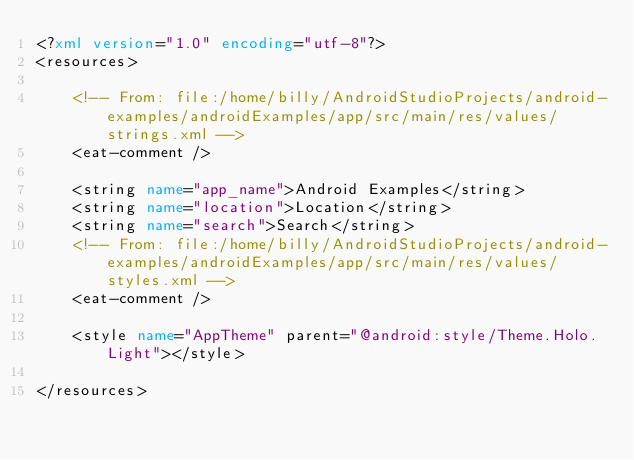Convert code to text. <code><loc_0><loc_0><loc_500><loc_500><_XML_><?xml version="1.0" encoding="utf-8"?>
<resources>

    <!-- From: file:/home/billy/AndroidStudioProjects/android-examples/androidExamples/app/src/main/res/values/strings.xml -->
    <eat-comment />

    <string name="app_name">Android Examples</string>
    <string name="location">Location</string>
    <string name="search">Search</string>
    <!-- From: file:/home/billy/AndroidStudioProjects/android-examples/androidExamples/app/src/main/res/values/styles.xml -->
    <eat-comment />

    <style name="AppTheme" parent="@android:style/Theme.Holo.Light"></style>

</resources>
</code> 